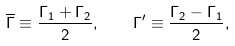Convert formula to latex. <formula><loc_0><loc_0><loc_500><loc_500>\overline { \Gamma } \equiv \frac { \Gamma _ { 1 } + \Gamma _ { 2 } } { 2 } , \quad \Gamma ^ { \prime } \equiv \frac { \Gamma _ { 2 } - \Gamma _ { 1 } } { 2 } ,</formula> 